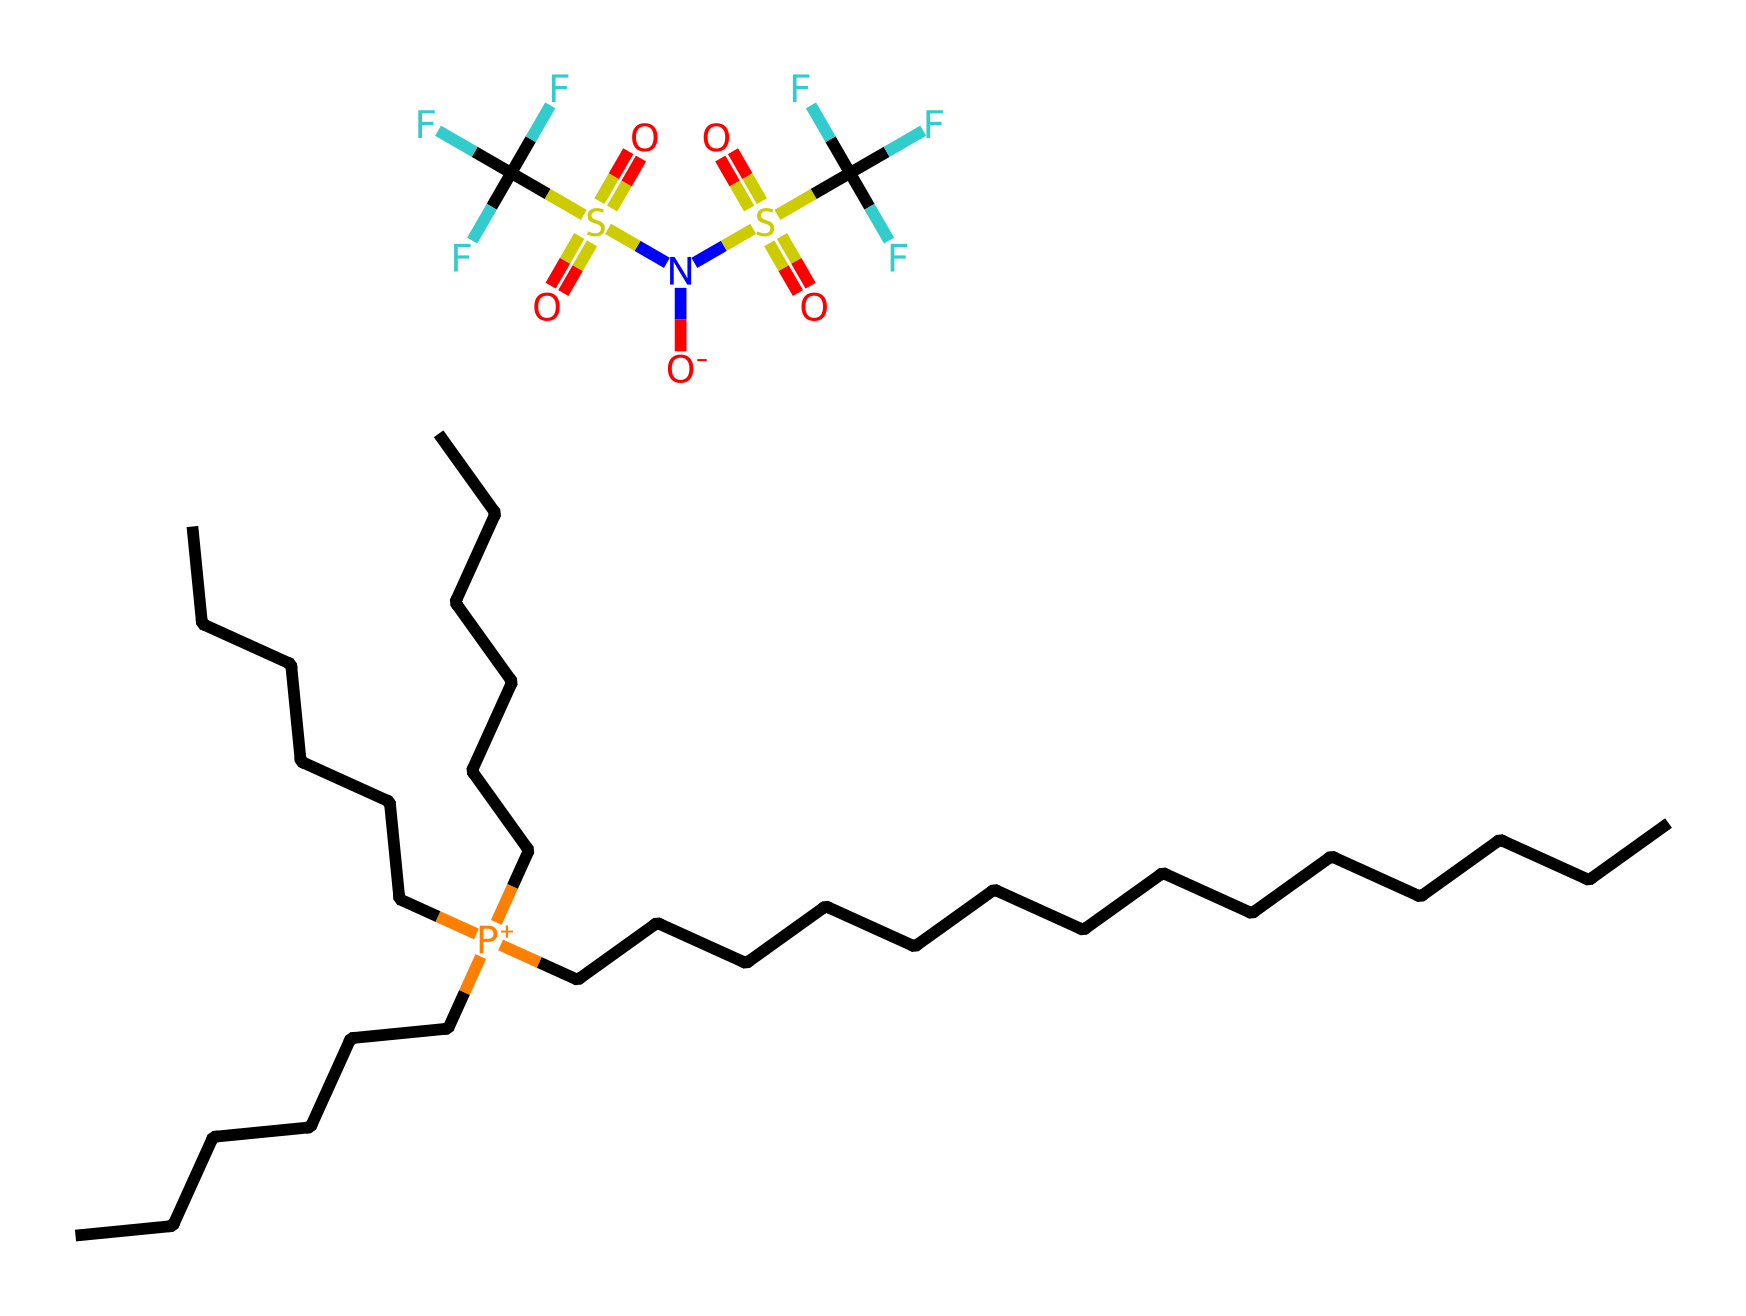What is the name of this ionic liquid? The chemical is named trihexyl(tetradecyl)phosphonium bis(trifluoromethylsulfonyl)imide. This conclusion is drawn from the SMILES representation, which includes specific naming conventions for the phosphonium cation and the anion.
Answer: trihexyl(tetradecyl)phosphonium bis(trifluoromethylsulfonyl)imide How many carbon atoms are in the alkyl chain of the cation? The cation trihexyl(tetradecyl)phosphonium has three hexyl groups, each contributing 6 carbon atoms, and one tetradecyl group contributing 14 carbon atoms. So, the total number of carbon atoms is calculated as follows: 3 * 6 + 14 = 32.
Answer: 32 What type of anion is present in this ionic liquid? The anion in this ionic liquid is bis(trifluoromethylsulfonyl)imide. This is identified from the part of the SMILES that represents the anion, which shows trifluoromethyl groups and a sulfonyl structure attached to an imide.
Answer: bis(trifluoromethylsulfonyl)imide How many sulfur atoms are in the chemical structure? The structure contains two sulfur atoms; one from each of the two sulfonyl groups in the bis(trifluoromethylsulfonyl)imide anion. We can see two occurrences of "S" in the anion part of the SMILES.
Answer: 2 What charge does the phosphonium cation carry in this ionic liquid? The phosphonium cation trihexyl(tetradecyl)phosphonium carries a positive charge, indicated by the "[P+]" notation in the SMILES representation, highlighting its role as the positively charged component of the ionic liquid.
Answer: positive Is this ionic liquid hydrophobic or hydrophilic? This ionic liquid is hydrophobic due to its long alkyl chains (the trihexyl and tetradecyl groups), which are non-polar and reduce solubility in water. This characteristic is typical of many ionic liquids with large organic cations.
Answer: hydrophobic What is the primary application of this ionic liquid? This ionic liquid is primarily used in metal extraction. The understanding comes from its application in solvent systems, which enable the extraction of metals due to its specific properties as an ionic liquid.
Answer: metal extraction 